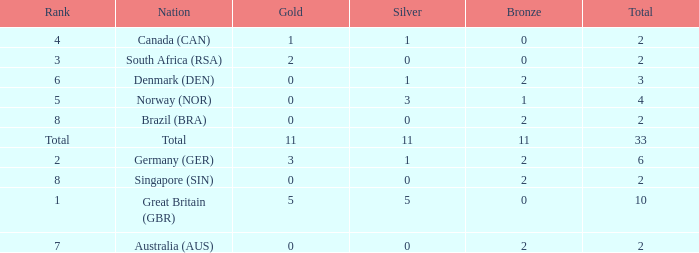What is bronze when the rank is 3 and the total is more than 2? None. 